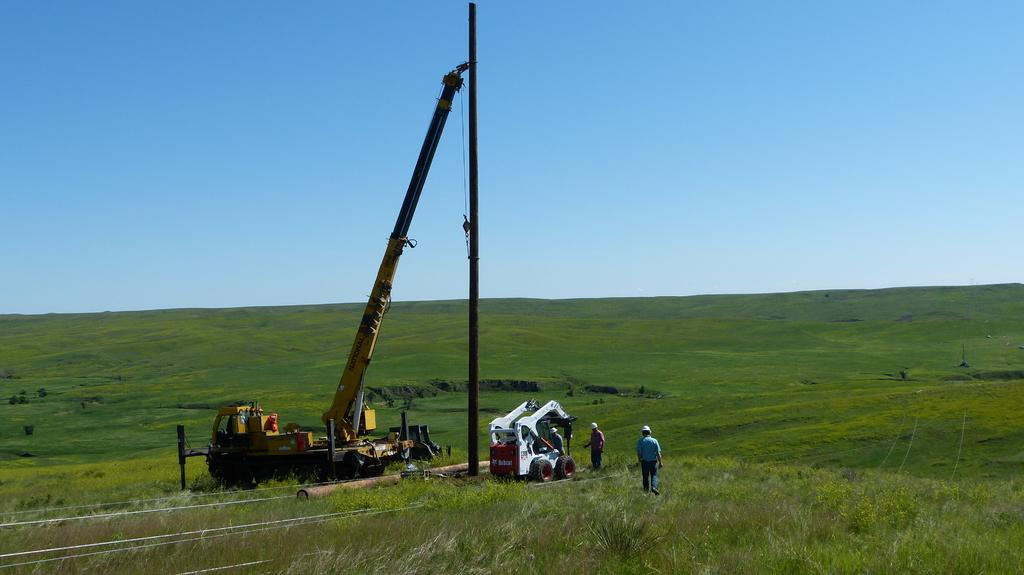What types of objects are on the ground in the image? There are vehicles on the ground in the image. What structures can be seen in the image? There are poles in the image. What type of vegetation is present in the image? There is grass in the image. What else can be seen in the image besides the ground and structures? There are wires in the image. Are there any living beings in the image? Yes, there are people in the image. What can be seen in the background of the image? The sky is visible in the background of the image. How many animals are present in the image? There are no animals present in the image. What type of spy equipment can be seen in the image? There is no spy equipment present in the image. 